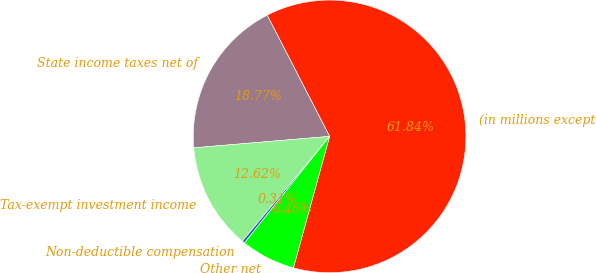Convert chart. <chart><loc_0><loc_0><loc_500><loc_500><pie_chart><fcel>(in millions except<fcel>State income taxes net of<fcel>Tax-exempt investment income<fcel>Non-deductible compensation<fcel>Other net<nl><fcel>61.85%<fcel>18.77%<fcel>12.62%<fcel>0.31%<fcel>6.46%<nl></chart> 